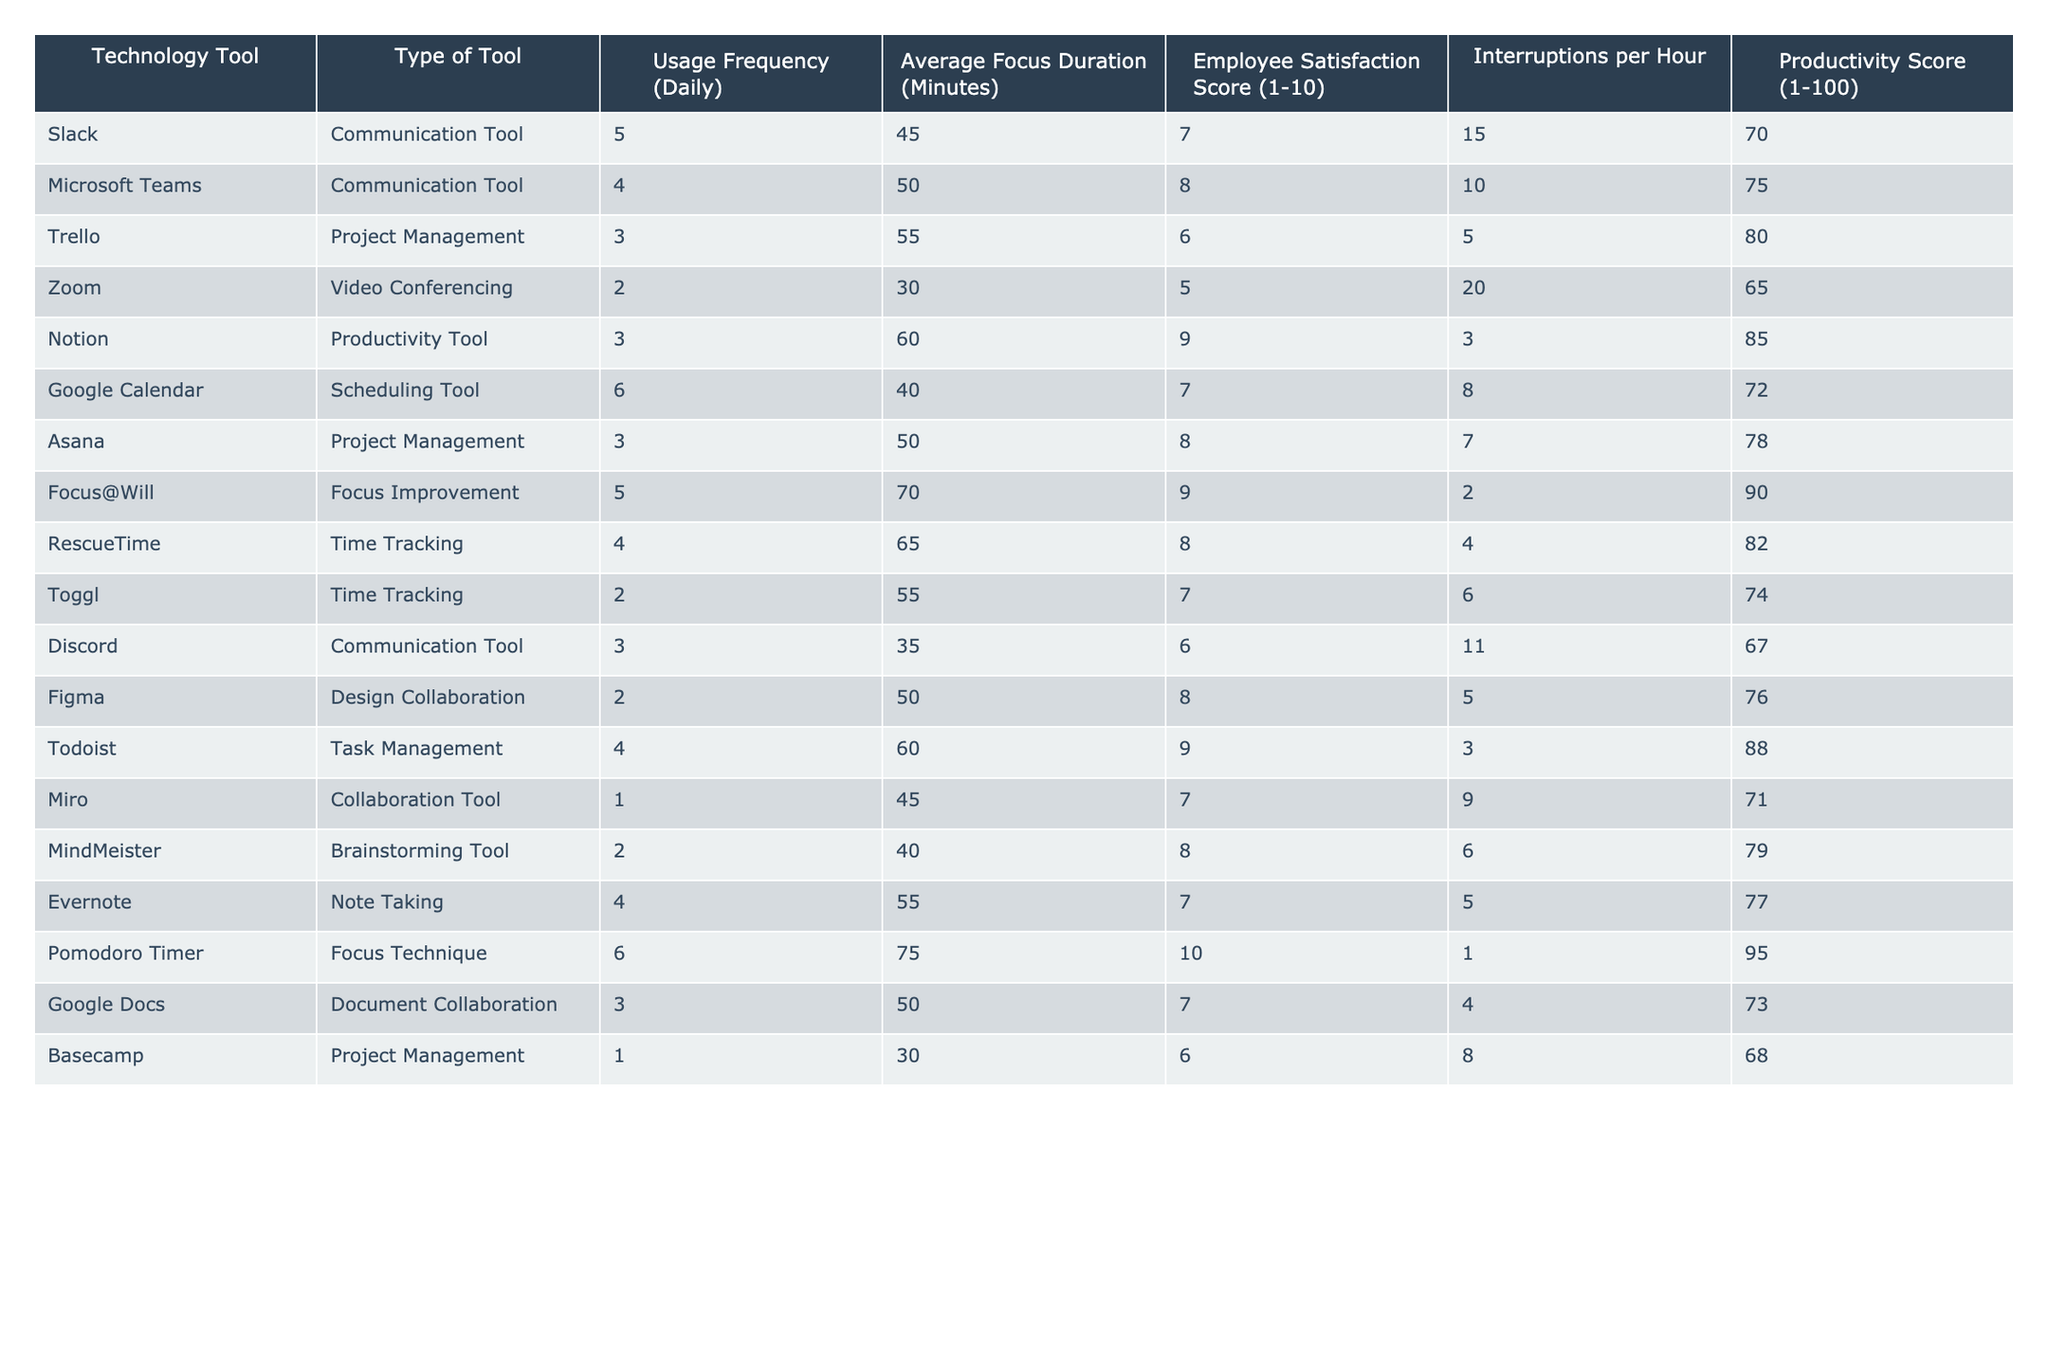What is the highest Employee Satisfaction Score among the tools? By scanning the "Employee Satisfaction Score" column, we identify the highest value, which is 10 for the Pomodoro Timer tool.
Answer: 10 Which technology tool has the maximum Usage Frequency? In the "Usage Frequency (Daily)" column, the highest value is 6, associated with Google Calendar and Pomodoro Timer.
Answer: 6 What is the average Average Focus Duration of Communication Tools? The focus duration for communication tools (Slack, Microsoft Teams, Zoom, Discord) is (45 + 50 + 30 + 35) / 4 = 40.
Answer: 40 Is the Productivity Score of Notion higher than that of Asana? Notion has a Productivity Score of 85, while Asana has a score of 78; since 85 > 78, the statement is true.
Answer: Yes Which tool has the least Interruptions per Hour? Looking at the "Interruptions per Hour" column, Focus@Will has the least interruptions at 2.
Answer: 2 What is the total Productivity Score for all Project Management tools? The Productivity Scores for Project Management tools (Trello, Asana, Basecamp) are 80, 78, and 68. The total is 80 + 78 + 68 = 226.
Answer: 226 Is there a correlation between Usage Frequency and Average Focus Duration? To determine correlation, we note both columns: usage frequency values range from 1 to 6, with varying focus durations (30 to 75). However, the relationship does not present a clear trend, making correlation weak.
Answer: No clear correlation How much higher is the Average Focus Duration of Pomodoro Timer compared to Zoom? The Average Focus Duration for Pomodoro Timer is 75 minutes and for Zoom is 30 minutes. Therefore, the difference is 75 - 30 = 45 minutes.
Answer: 45 minutes Which tool has the highest Productivity Score and how is it related to its Interruptions per Hour? Focus@Will has the highest Productivity Score of 90 and just 2 Interruptions per Hour. This shows it is effective even with low interruptions.
Answer: Focus@Will Are there any tools with an Employee Satisfaction Score of 10? Yes, the Pomodoro Timer has an Employee Satisfaction Score of 10.
Answer: Yes 